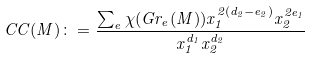<formula> <loc_0><loc_0><loc_500><loc_500>C C ( M ) \colon = \frac { \sum _ { e } \chi ( G r _ { e } ( M ) ) x _ { 1 } ^ { 2 ( d _ { 2 } - e _ { 2 } ) } x _ { 2 } ^ { 2 e _ { 1 } } } { x _ { 1 } ^ { d _ { 1 } } x _ { 2 } ^ { d _ { 2 } } }</formula> 